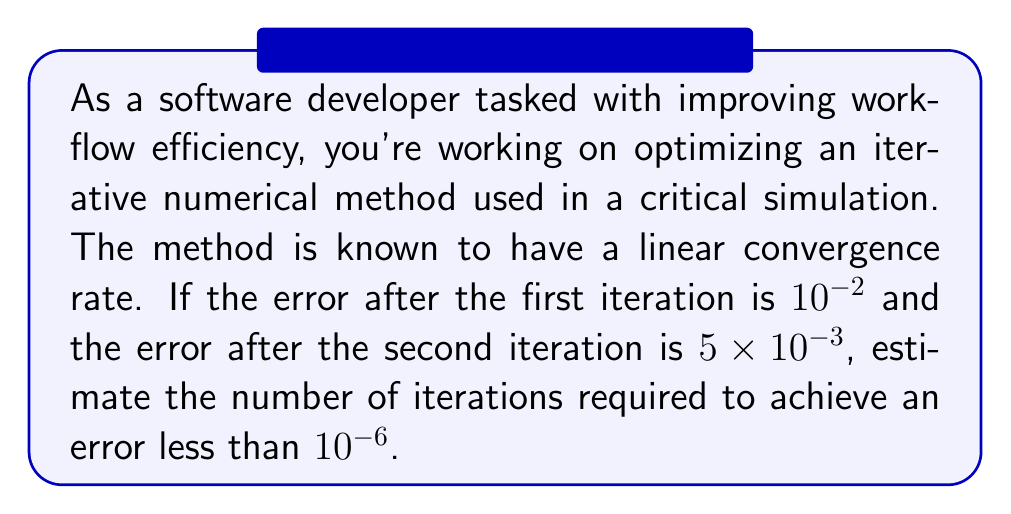What is the answer to this math problem? To solve this problem, we'll use the properties of linear convergence and estimate the convergence rate:

1) For linear convergence, we have:
   $$\frac{|e_{n+1}|}{|e_n|} \approx C$$
   where $C$ is the convergence rate, and $e_n$ is the error at iteration $n$.

2) Using the given information:
   $$C \approx \frac{|e_2|}{|e_1|} = \frac{5 \times 10^{-3}}{10^{-2}} = 0.5$$

3) We can express the error after $n$ iterations as:
   $$|e_n| \approx |e_1| \cdot C^{n-1}$$

4) We want to find $n$ such that:
   $$|e_n| < 10^{-6}$$

5) Substituting:
   $$10^{-2} \cdot (0.5)^{n-1} < 10^{-6}$$

6) Taking logarithms (base 2) of both sides:
   $$\log_2(10^{-2}) + (n-1)\log_2(0.5) < \log_2(10^{-6})$$

7) Simplifying:
   $$-6.64 - (n-1) < -19.93$$
   $$n > 14.29$$

8) Since $n$ must be an integer, we round up to the next whole number.
Answer: The estimated number of iterations required to achieve an error less than $10^{-6}$ is 15. 